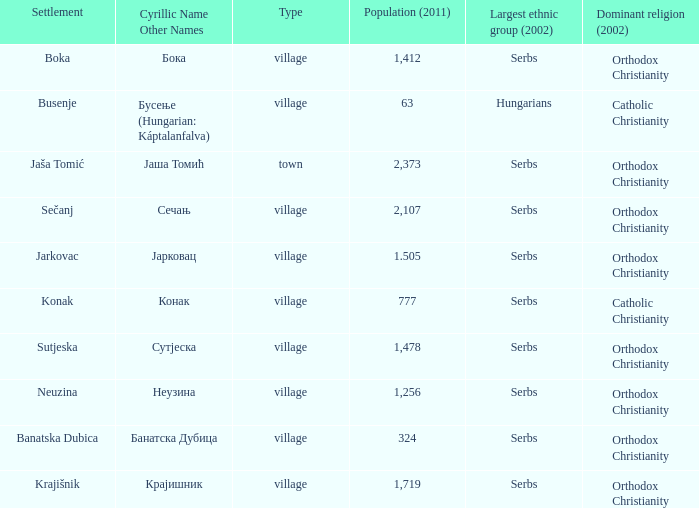What kind of type is  бока? Village. 